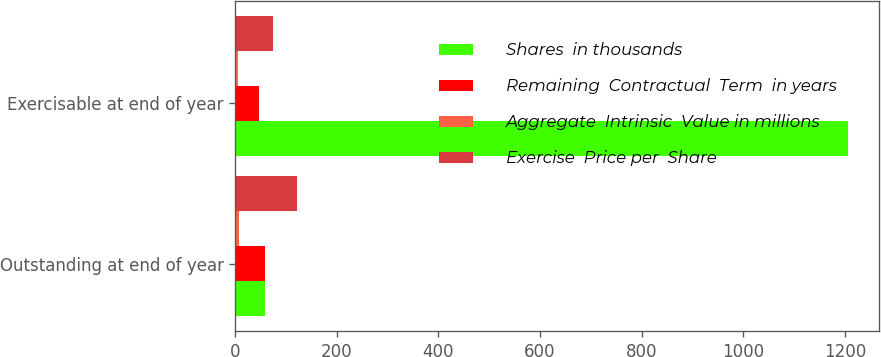Convert chart to OTSL. <chart><loc_0><loc_0><loc_500><loc_500><stacked_bar_chart><ecel><fcel>Outstanding at end of year<fcel>Exercisable at end of year<nl><fcel>Shares  in thousands<fcel>58.35<fcel>1206<nl><fcel>Remaining  Contractual  Term  in years<fcel>58.35<fcel>46.81<nl><fcel>Aggregate  Intrinsic  Value in millions<fcel>7<fcel>5.5<nl><fcel>Exercise  Price per  Share<fcel>121.2<fcel>74.1<nl></chart> 